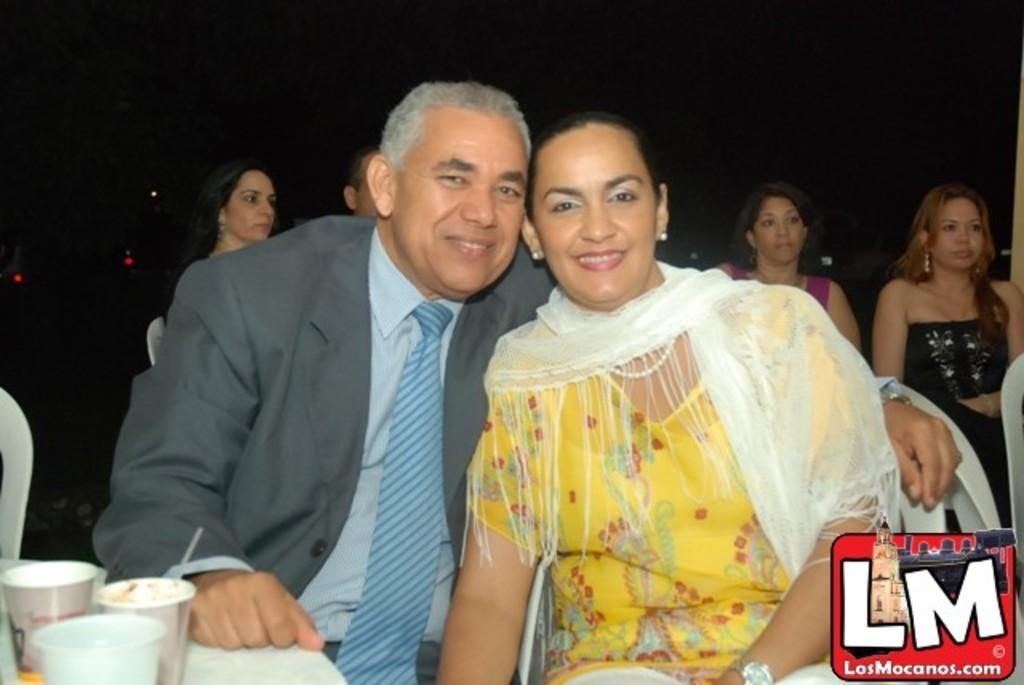Can you describe this image briefly? In this picture there is a man and a woman those who are sitting in the center of the image and there is a table in the bottom left side of the image on which, there are glasses and there are other people in the background area of the image. 